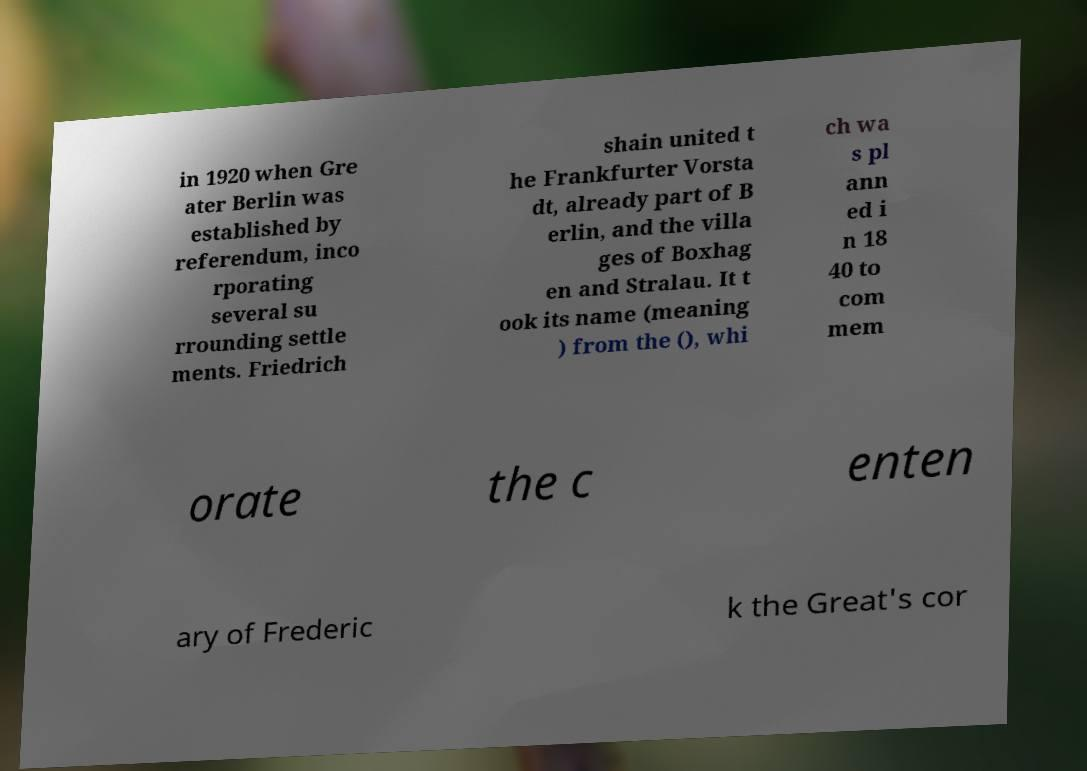Can you accurately transcribe the text from the provided image for me? in 1920 when Gre ater Berlin was established by referendum, inco rporating several su rrounding settle ments. Friedrich shain united t he Frankfurter Vorsta dt, already part of B erlin, and the villa ges of Boxhag en and Stralau. It t ook its name (meaning ) from the (), whi ch wa s pl ann ed i n 18 40 to com mem orate the c enten ary of Frederic k the Great's cor 